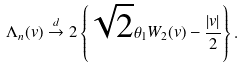Convert formula to latex. <formula><loc_0><loc_0><loc_500><loc_500>\Lambda _ { n } ( v ) \stackrel { d } { \to } 2 \left \{ \sqrt { 2 } \theta _ { 1 } W _ { 2 } ( v ) - \frac { | v | } { 2 } \right \} .</formula> 